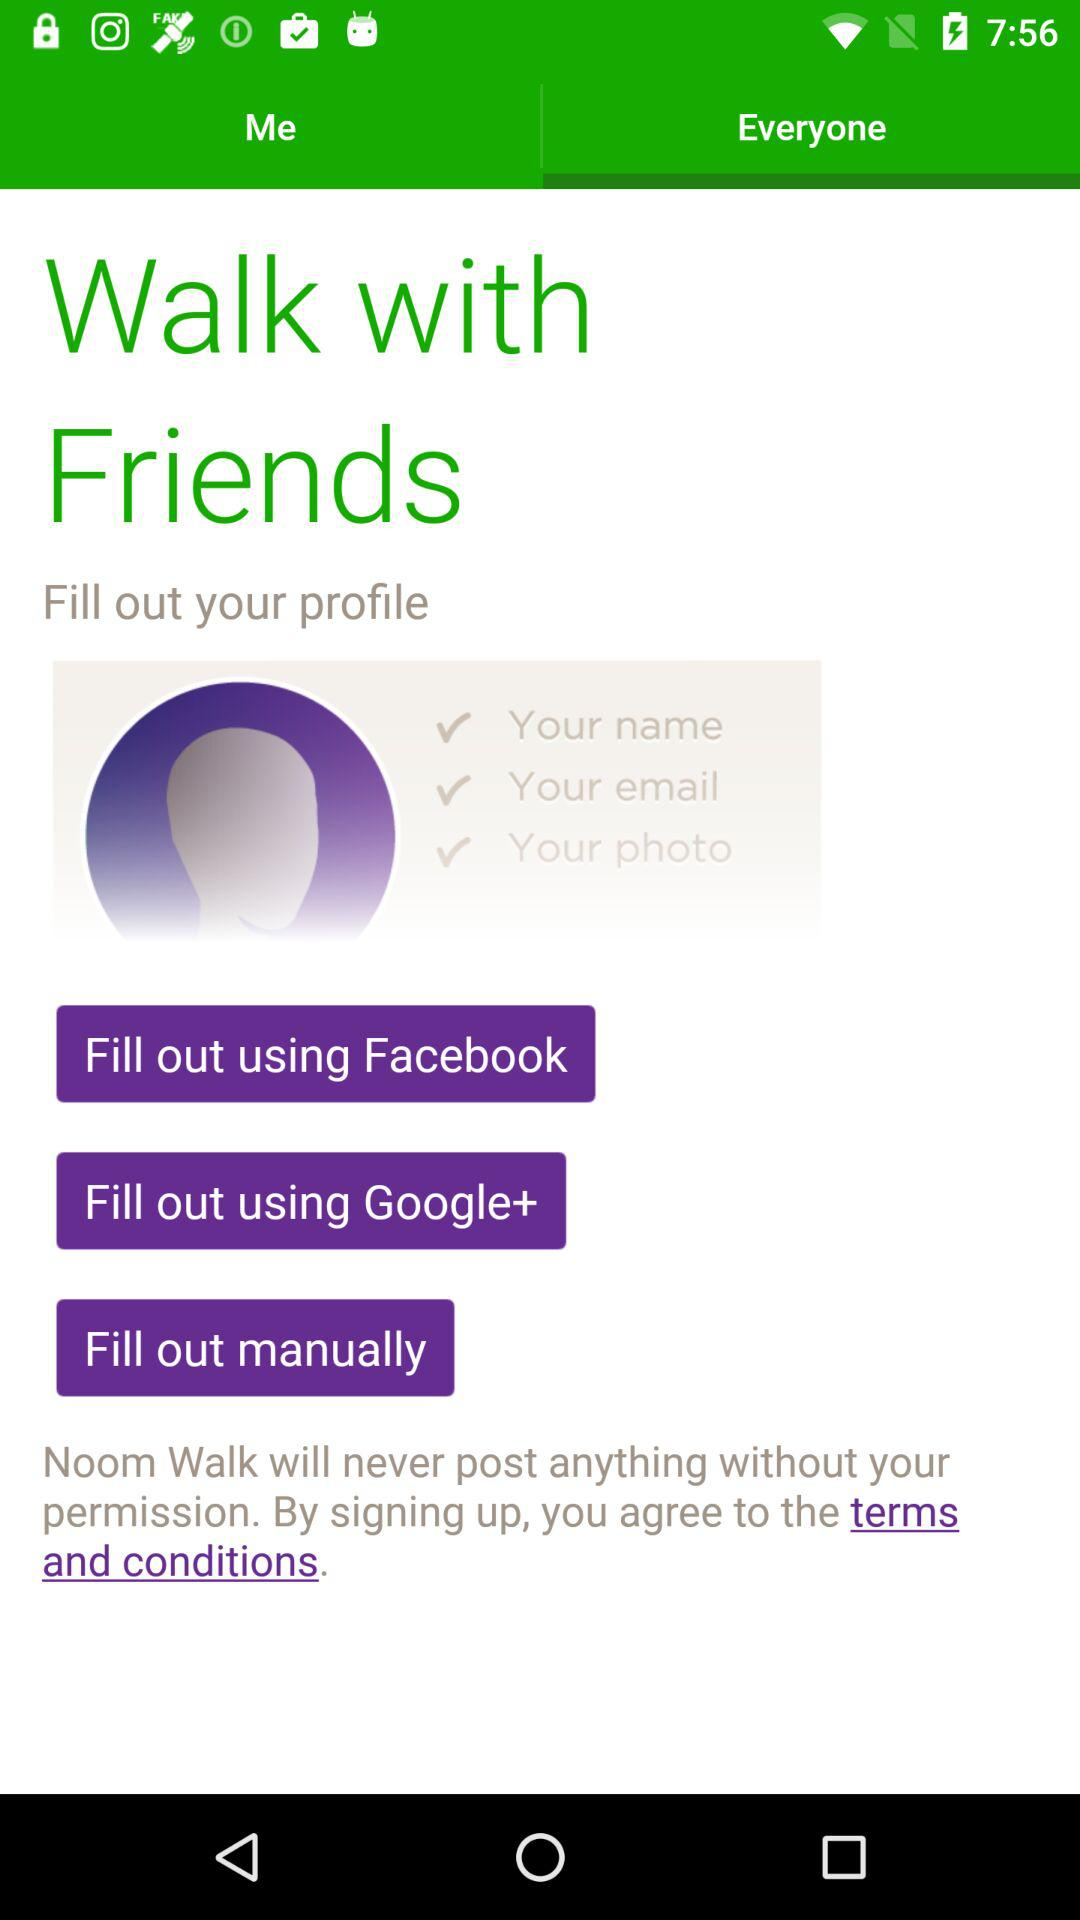How many ways are there to fill out your profile?
Answer the question using a single word or phrase. 3 